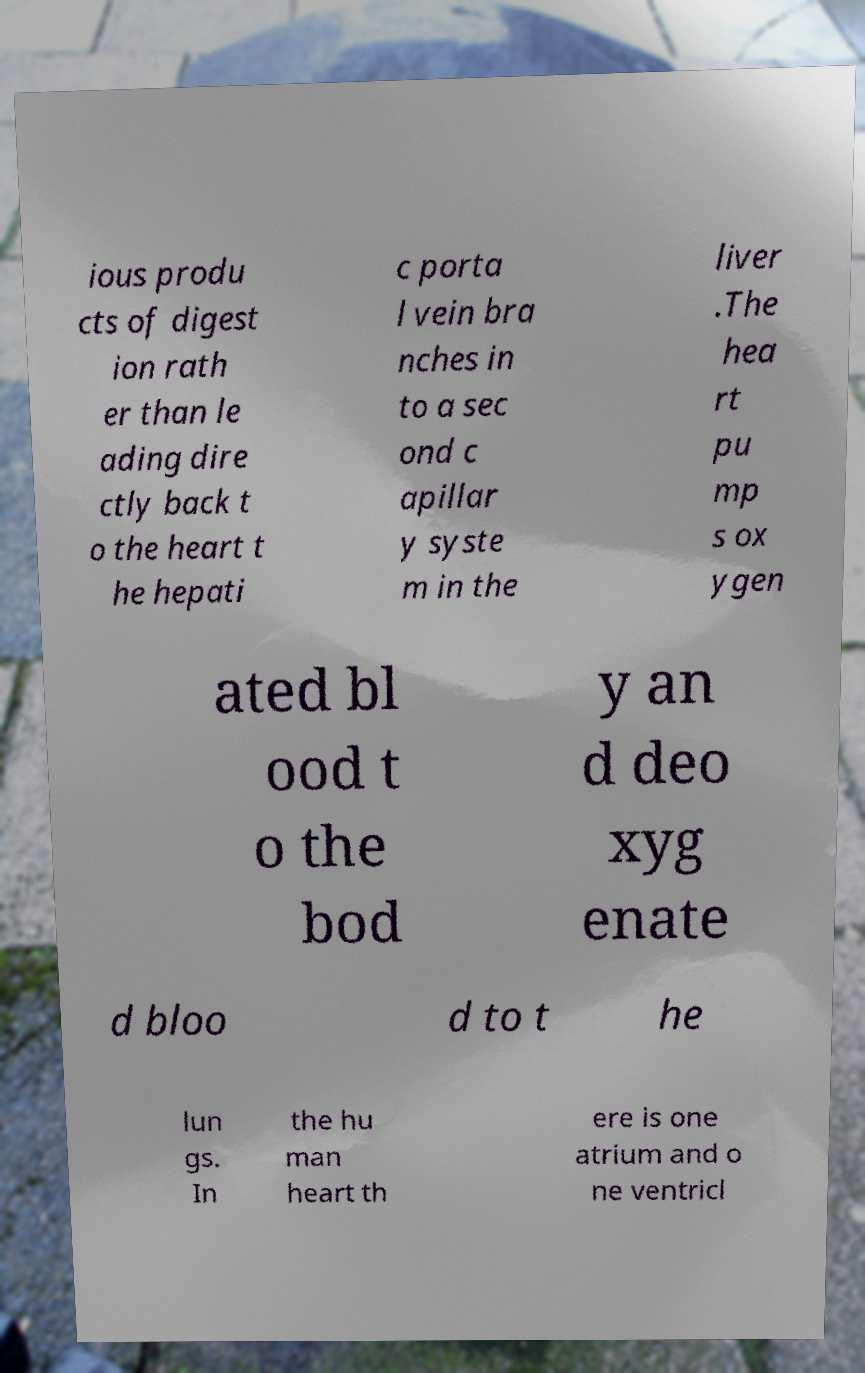What messages or text are displayed in this image? I need them in a readable, typed format. ious produ cts of digest ion rath er than le ading dire ctly back t o the heart t he hepati c porta l vein bra nches in to a sec ond c apillar y syste m in the liver .The hea rt pu mp s ox ygen ated bl ood t o the bod y an d deo xyg enate d bloo d to t he lun gs. In the hu man heart th ere is one atrium and o ne ventricl 